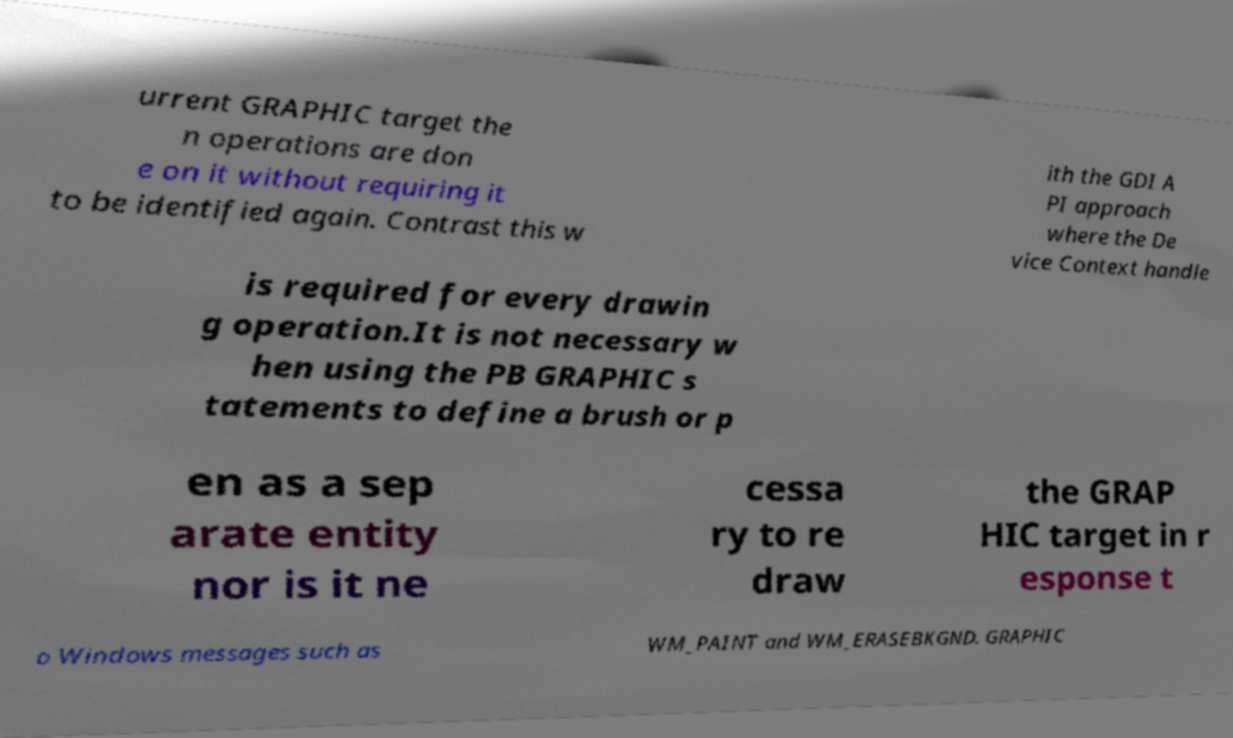I need the written content from this picture converted into text. Can you do that? urrent GRAPHIC target the n operations are don e on it without requiring it to be identified again. Contrast this w ith the GDI A PI approach where the De vice Context handle is required for every drawin g operation.It is not necessary w hen using the PB GRAPHIC s tatements to define a brush or p en as a sep arate entity nor is it ne cessa ry to re draw the GRAP HIC target in r esponse t o Windows messages such as WM_PAINT and WM_ERASEBKGND. GRAPHIC 